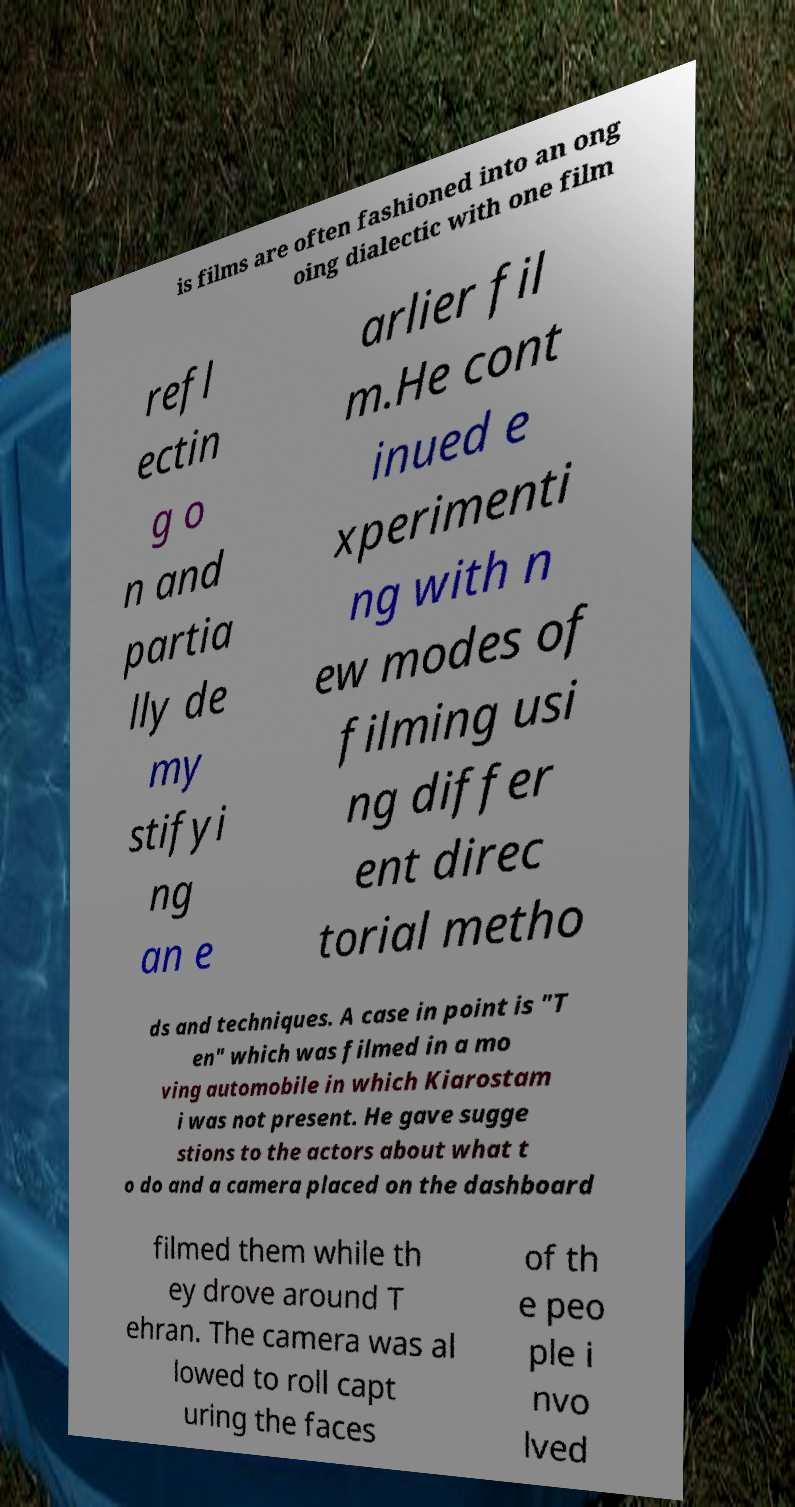Can you accurately transcribe the text from the provided image for me? is films are often fashioned into an ong oing dialectic with one film refl ectin g o n and partia lly de my stifyi ng an e arlier fil m.He cont inued e xperimenti ng with n ew modes of filming usi ng differ ent direc torial metho ds and techniques. A case in point is "T en" which was filmed in a mo ving automobile in which Kiarostam i was not present. He gave sugge stions to the actors about what t o do and a camera placed on the dashboard filmed them while th ey drove around T ehran. The camera was al lowed to roll capt uring the faces of th e peo ple i nvo lved 